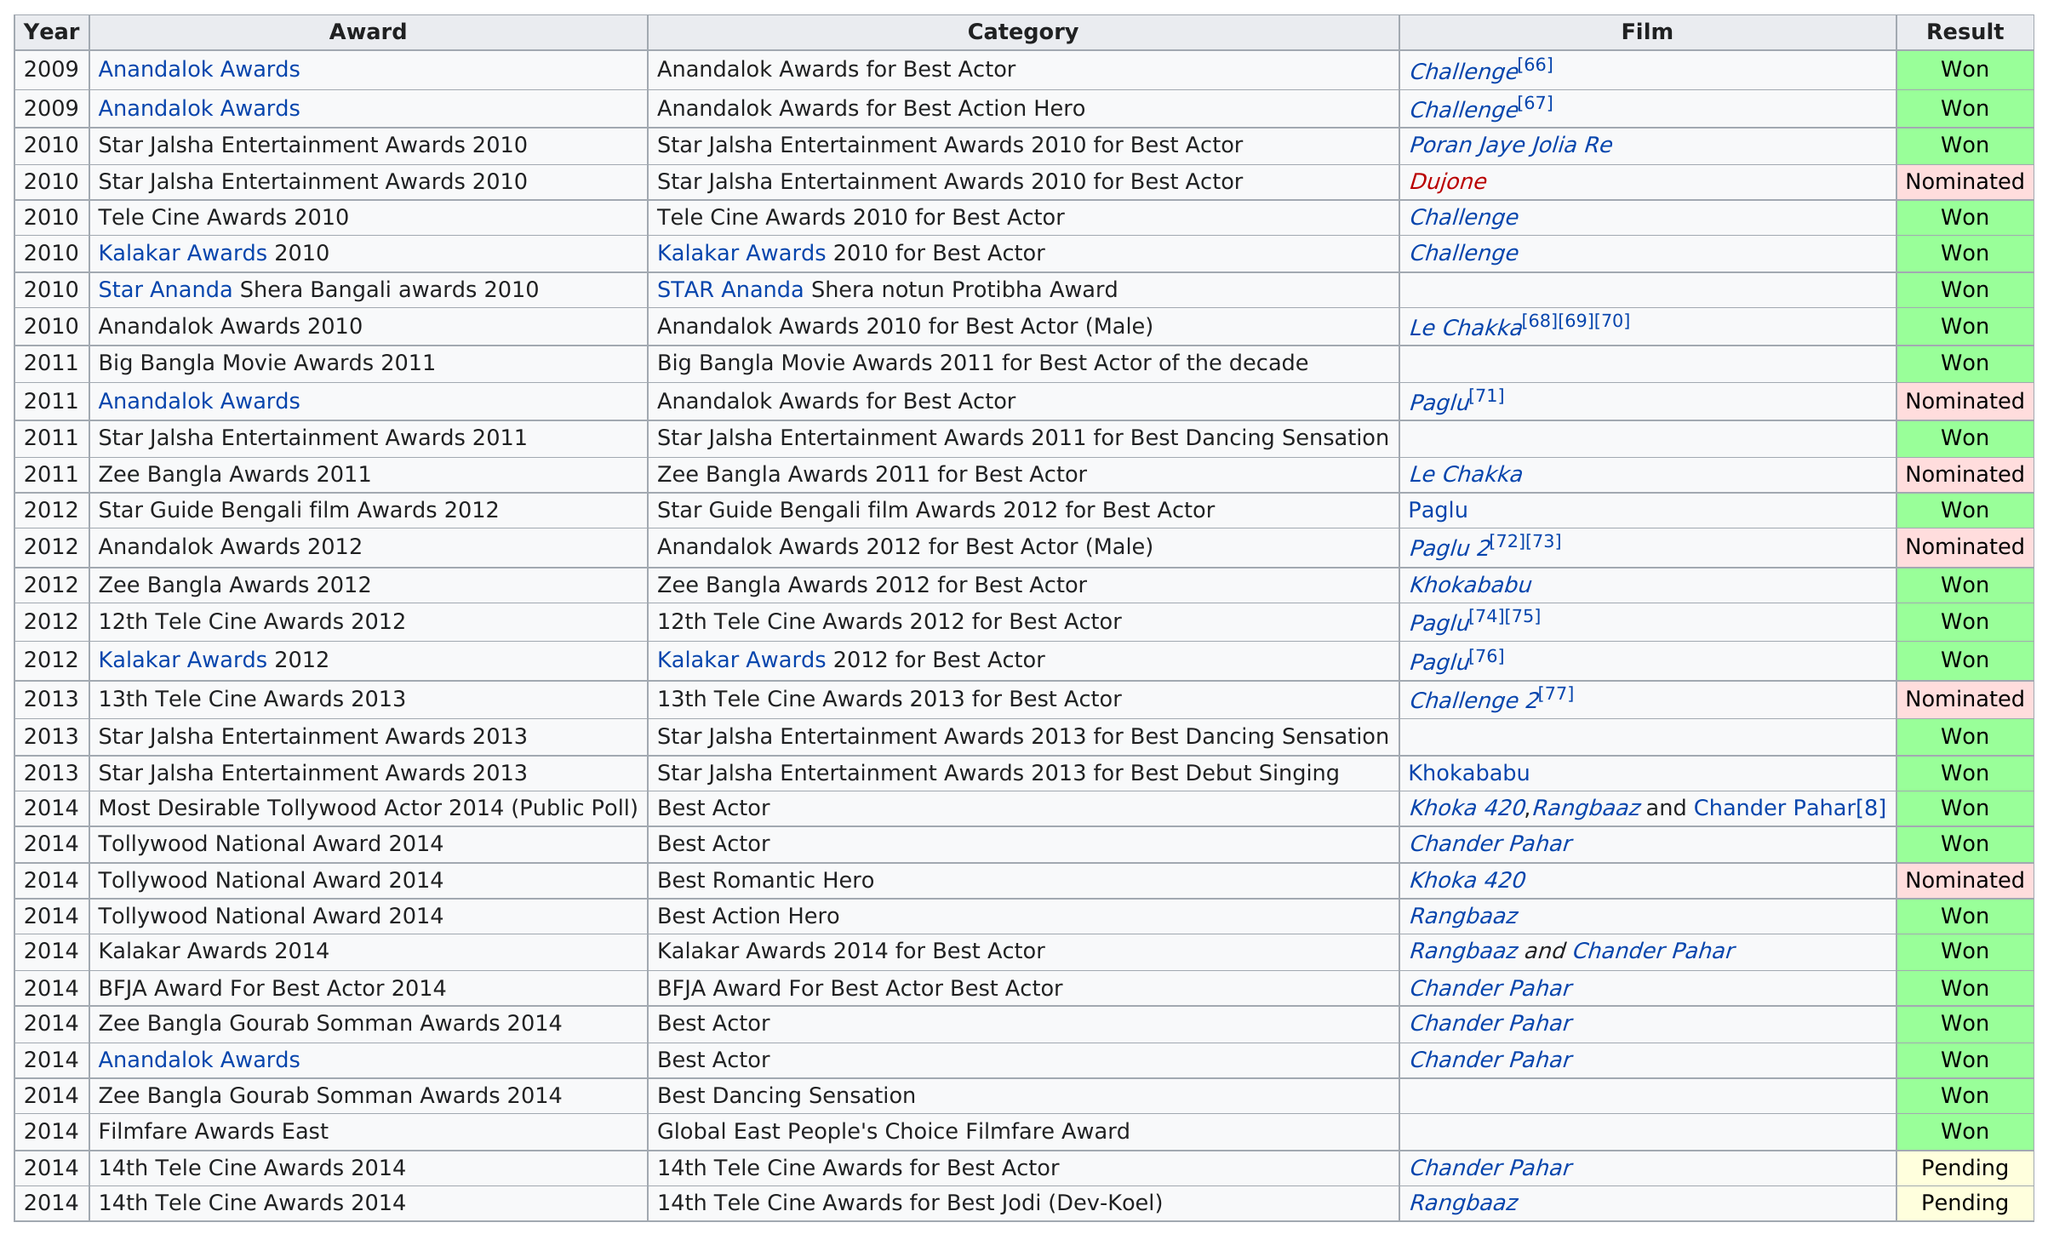Indicate a few pertinent items in this graphic. As of my knowledge cutoff date of September 2021, Developer's longest streak of consecutive wins without a loss was 7 games. Dev has received 11 awards after 2012. A total of 24 times was the result 'won'. This actor has received 4 star jalsa entertainment awards. The difference between the number of times the result was "won" and the number of times the result was "nominated" is 18. 